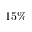<formula> <loc_0><loc_0><loc_500><loc_500>1 5 \%</formula> 